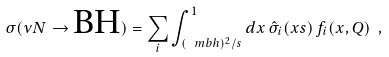Convert formula to latex. <formula><loc_0><loc_0><loc_500><loc_500>\sigma ( \nu N \to \text {BH} ) = \sum _ { i } \int _ { ( \ m b h ) ^ { 2 } / s } ^ { 1 } d x \, \hat { \sigma } _ { i } ( x s ) \, f _ { i } ( x , Q ) \ ,</formula> 